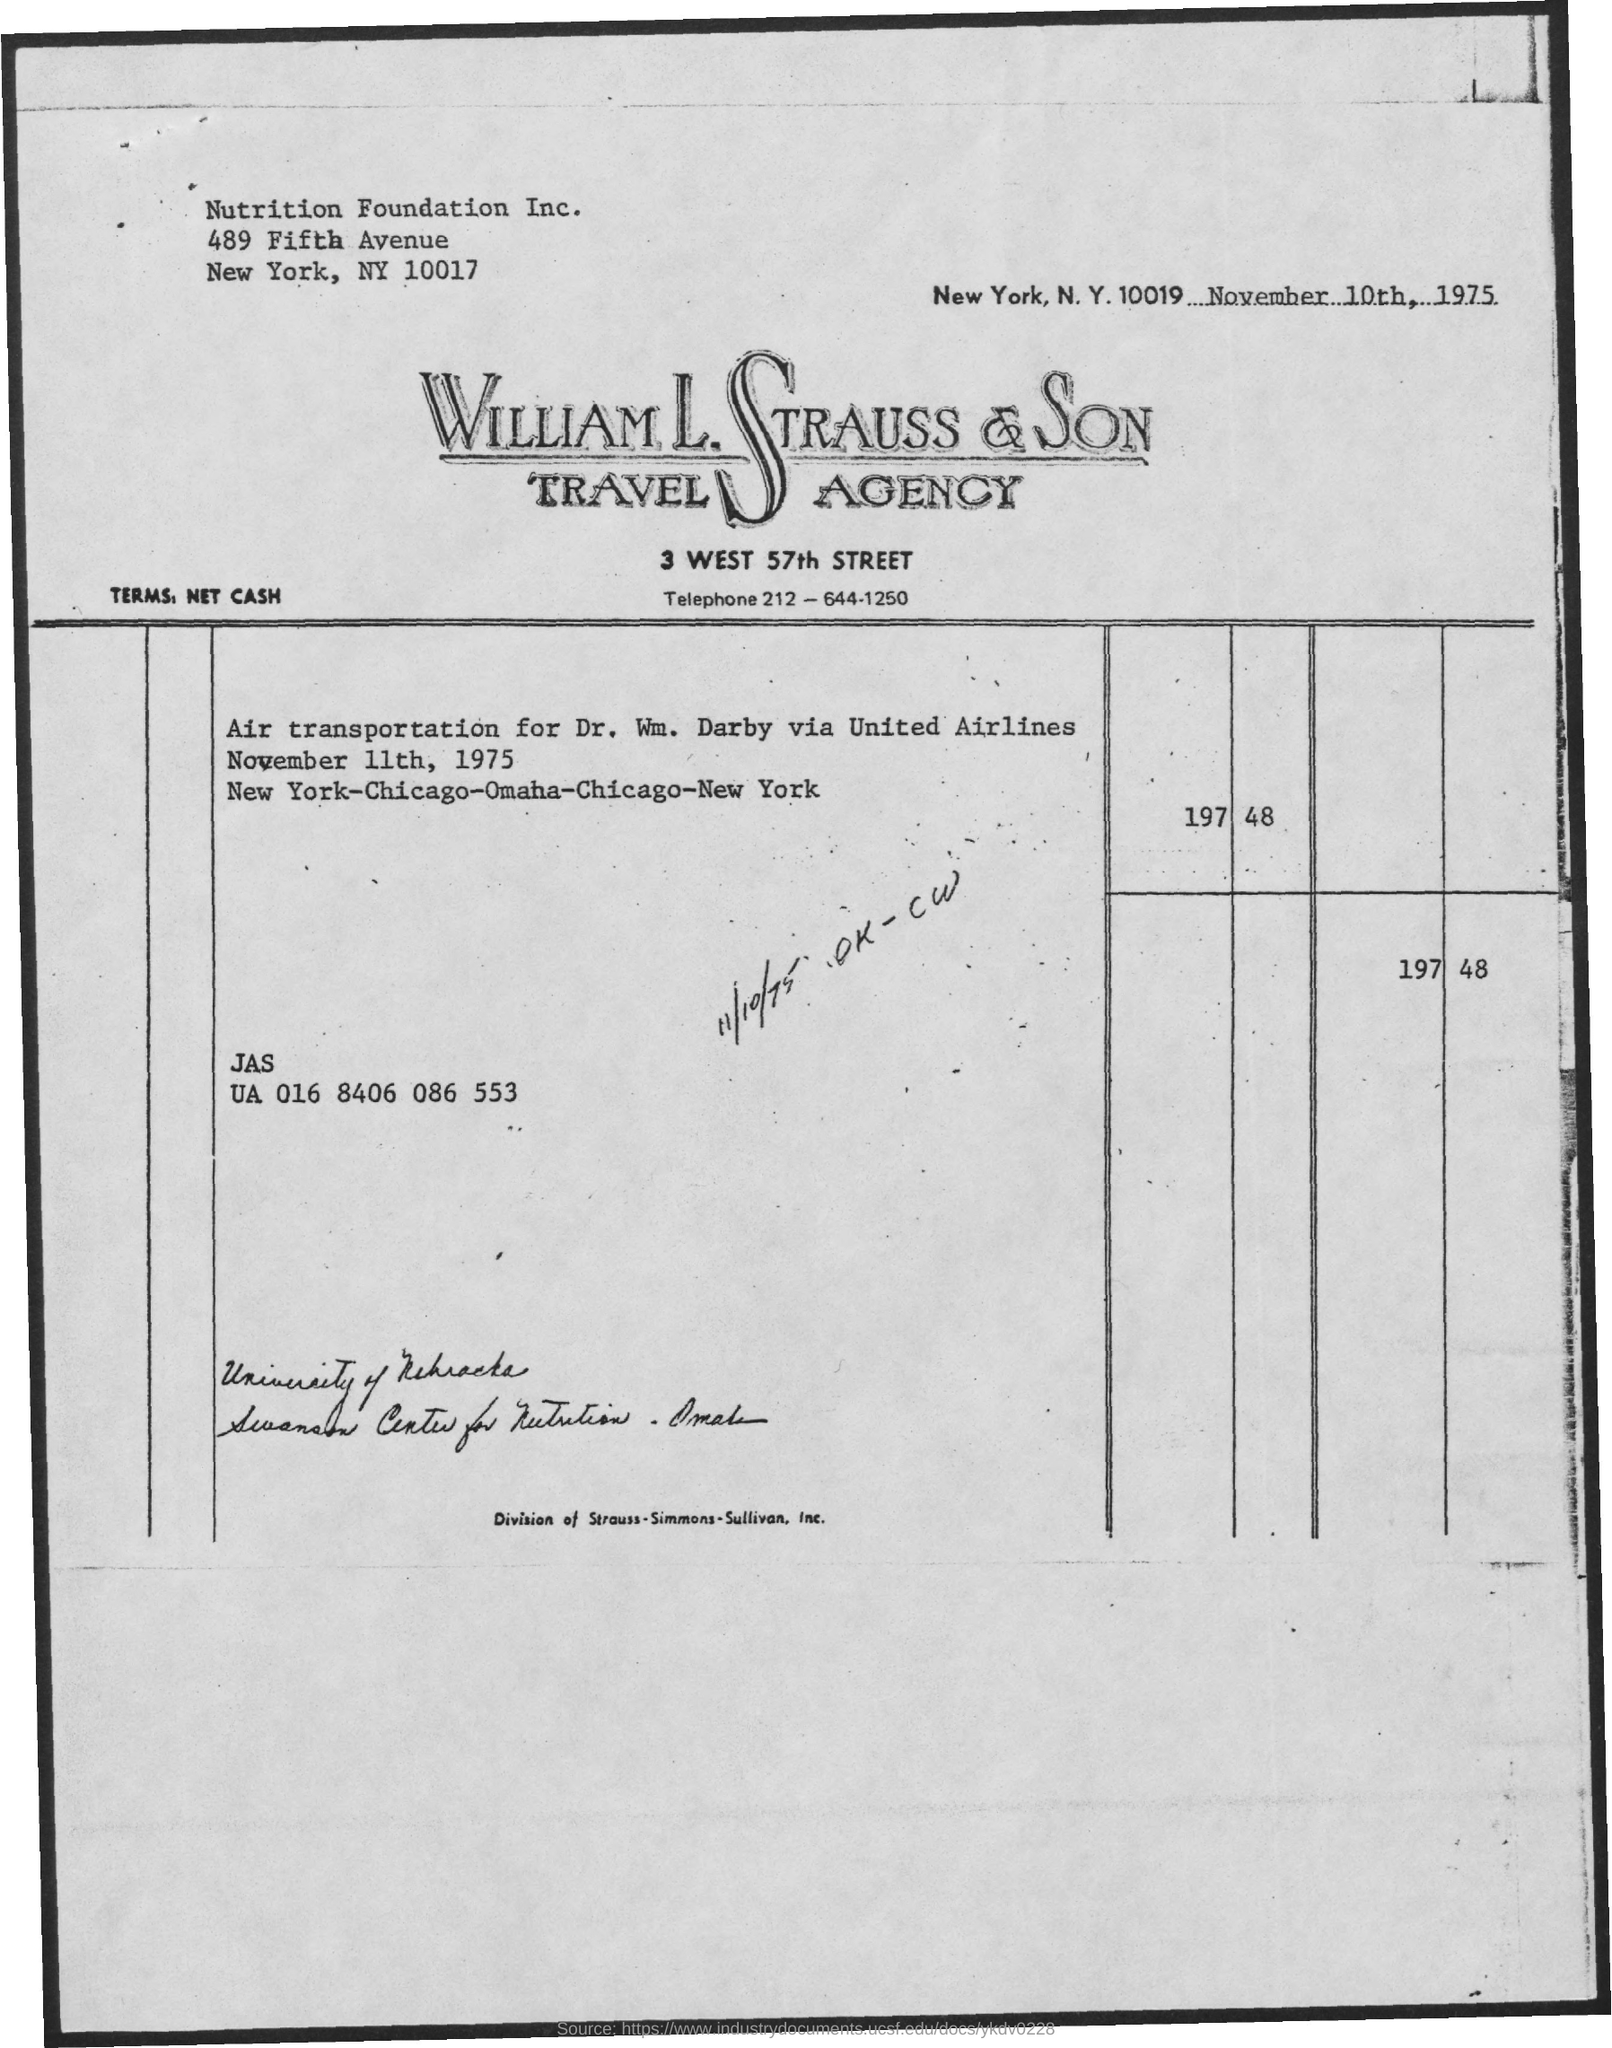When is the memorandum dated on ?
Keep it short and to the point. November 10th, 1975. 